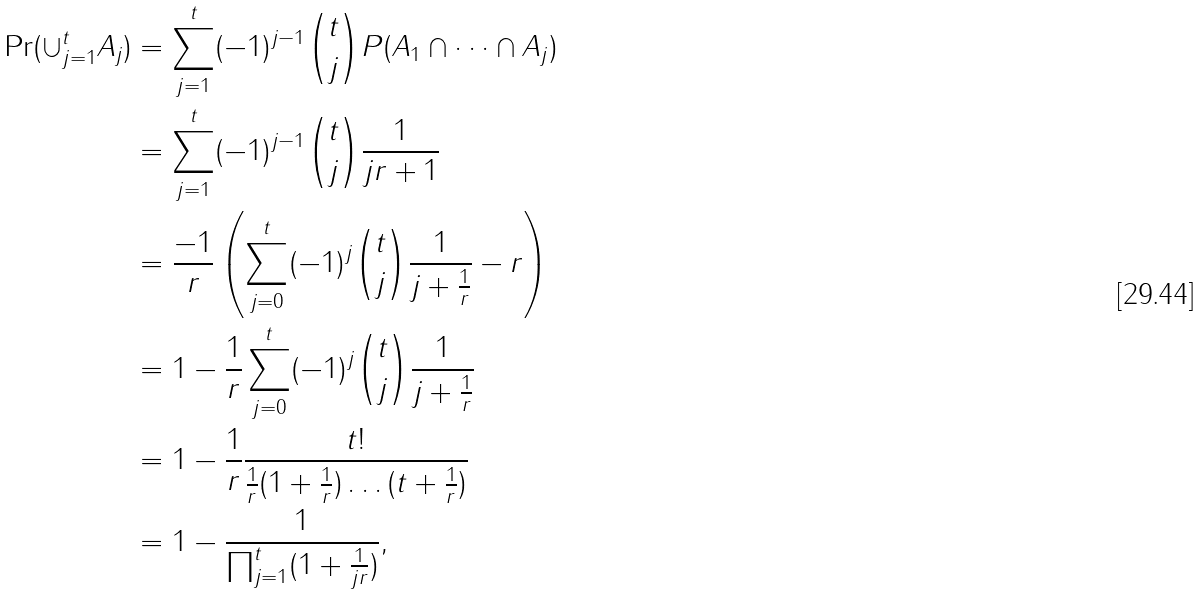<formula> <loc_0><loc_0><loc_500><loc_500>\Pr ( \cup _ { j = 1 } ^ { t } A _ { j } ) & = \sum _ { j = 1 } ^ { t } ( - 1 ) ^ { j - 1 } \binom { t } { j } P ( A _ { 1 } \cap \dots \cap A _ { j } ) \\ & = \sum _ { j = 1 } ^ { t } ( - 1 ) ^ { j - 1 } \binom { t } { j } \frac { 1 } { j r + 1 } \\ & = \frac { - 1 } { r } \left ( \sum _ { j = 0 } ^ { t } ( - 1 ) ^ { j } \binom { t } { j } \frac { 1 } { j + \frac { 1 } { r } } - r \right ) \\ & = 1 - \frac { 1 } { r } \sum _ { j = 0 } ^ { t } ( - 1 ) ^ { j } \binom { t } { j } \frac { 1 } { j + \frac { 1 } { r } } \\ & = 1 - \frac { 1 } { r } \frac { t ! } { \frac { 1 } { r } ( 1 + \frac { 1 } { r } ) \dots ( t + \frac { 1 } { r } ) } \\ & = 1 - \frac { 1 } { \prod _ { j = 1 } ^ { t } ( 1 + \frac { 1 } { j r } ) } ,</formula> 